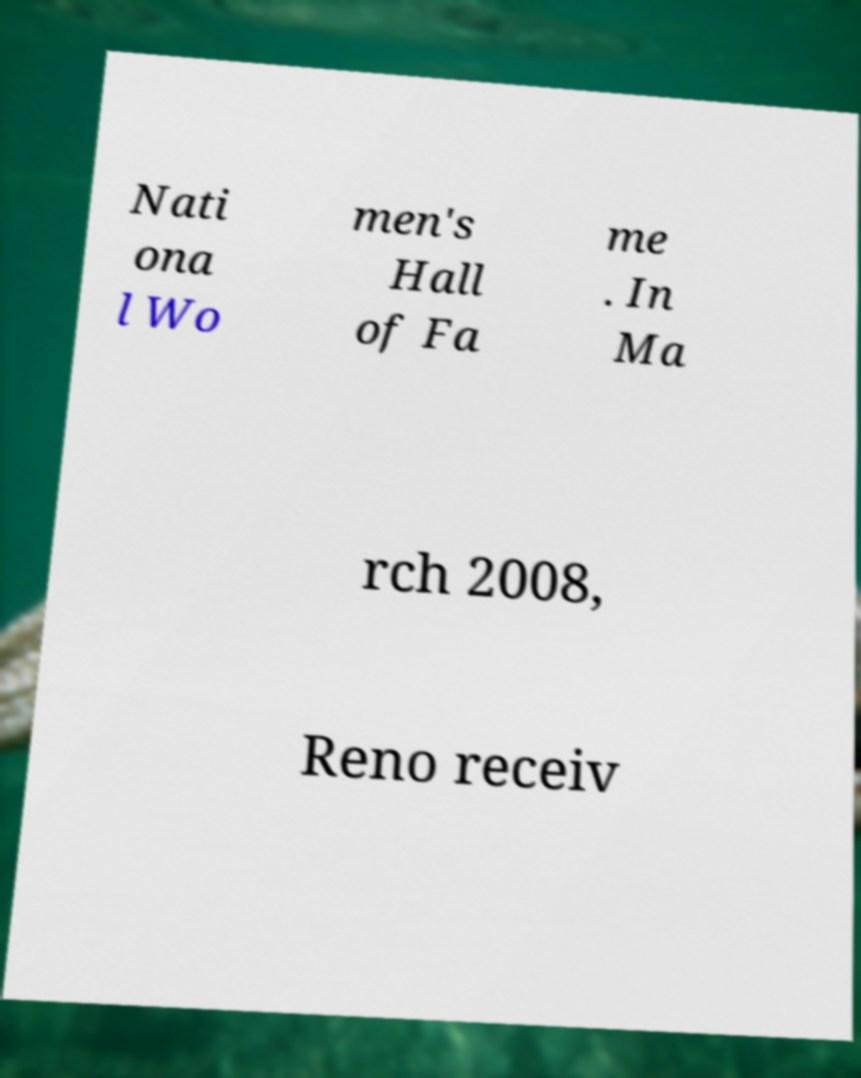Can you read and provide the text displayed in the image?This photo seems to have some interesting text. Can you extract and type it out for me? Nati ona l Wo men's Hall of Fa me . In Ma rch 2008, Reno receiv 